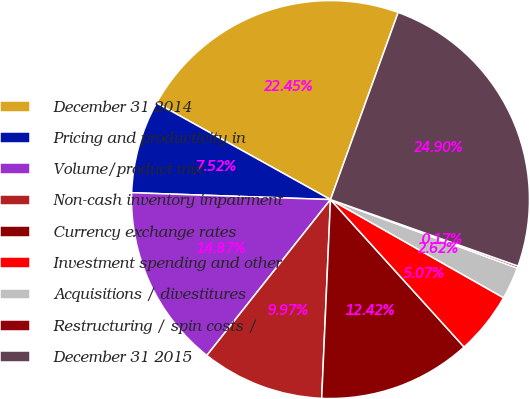Convert chart. <chart><loc_0><loc_0><loc_500><loc_500><pie_chart><fcel>December 31 2014<fcel>Pricing and productivity in<fcel>Volume/product mix<fcel>Non-cash inventory impairment<fcel>Currency exchange rates<fcel>Investment spending and other<fcel>Acquisitions / divestitures<fcel>Restructuring / spin costs /<fcel>December 31 2015<nl><fcel>22.45%<fcel>7.52%<fcel>14.87%<fcel>9.97%<fcel>12.42%<fcel>5.07%<fcel>2.62%<fcel>0.17%<fcel>24.9%<nl></chart> 